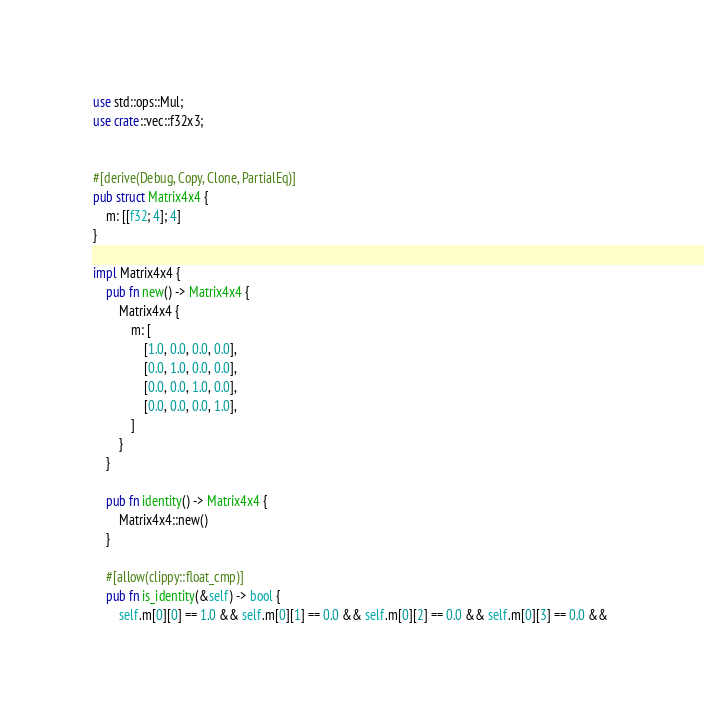Convert code to text. <code><loc_0><loc_0><loc_500><loc_500><_Rust_>use std::ops::Mul;
use crate::vec::f32x3;


#[derive(Debug, Copy, Clone, PartialEq)]
pub struct Matrix4x4 {
    m: [[f32; 4]; 4]
}

impl Matrix4x4 {
    pub fn new() -> Matrix4x4 {
        Matrix4x4 {
            m: [
                [1.0, 0.0, 0.0, 0.0],
                [0.0, 1.0, 0.0, 0.0],
                [0.0, 0.0, 1.0, 0.0],
                [0.0, 0.0, 0.0, 1.0],
            ]
        }
    }

    pub fn identity() -> Matrix4x4 {
        Matrix4x4::new()
    }

    #[allow(clippy::float_cmp)]
    pub fn is_identity(&self) -> bool {
        self.m[0][0] == 1.0 && self.m[0][1] == 0.0 && self.m[0][2] == 0.0 && self.m[0][3] == 0.0 && </code> 